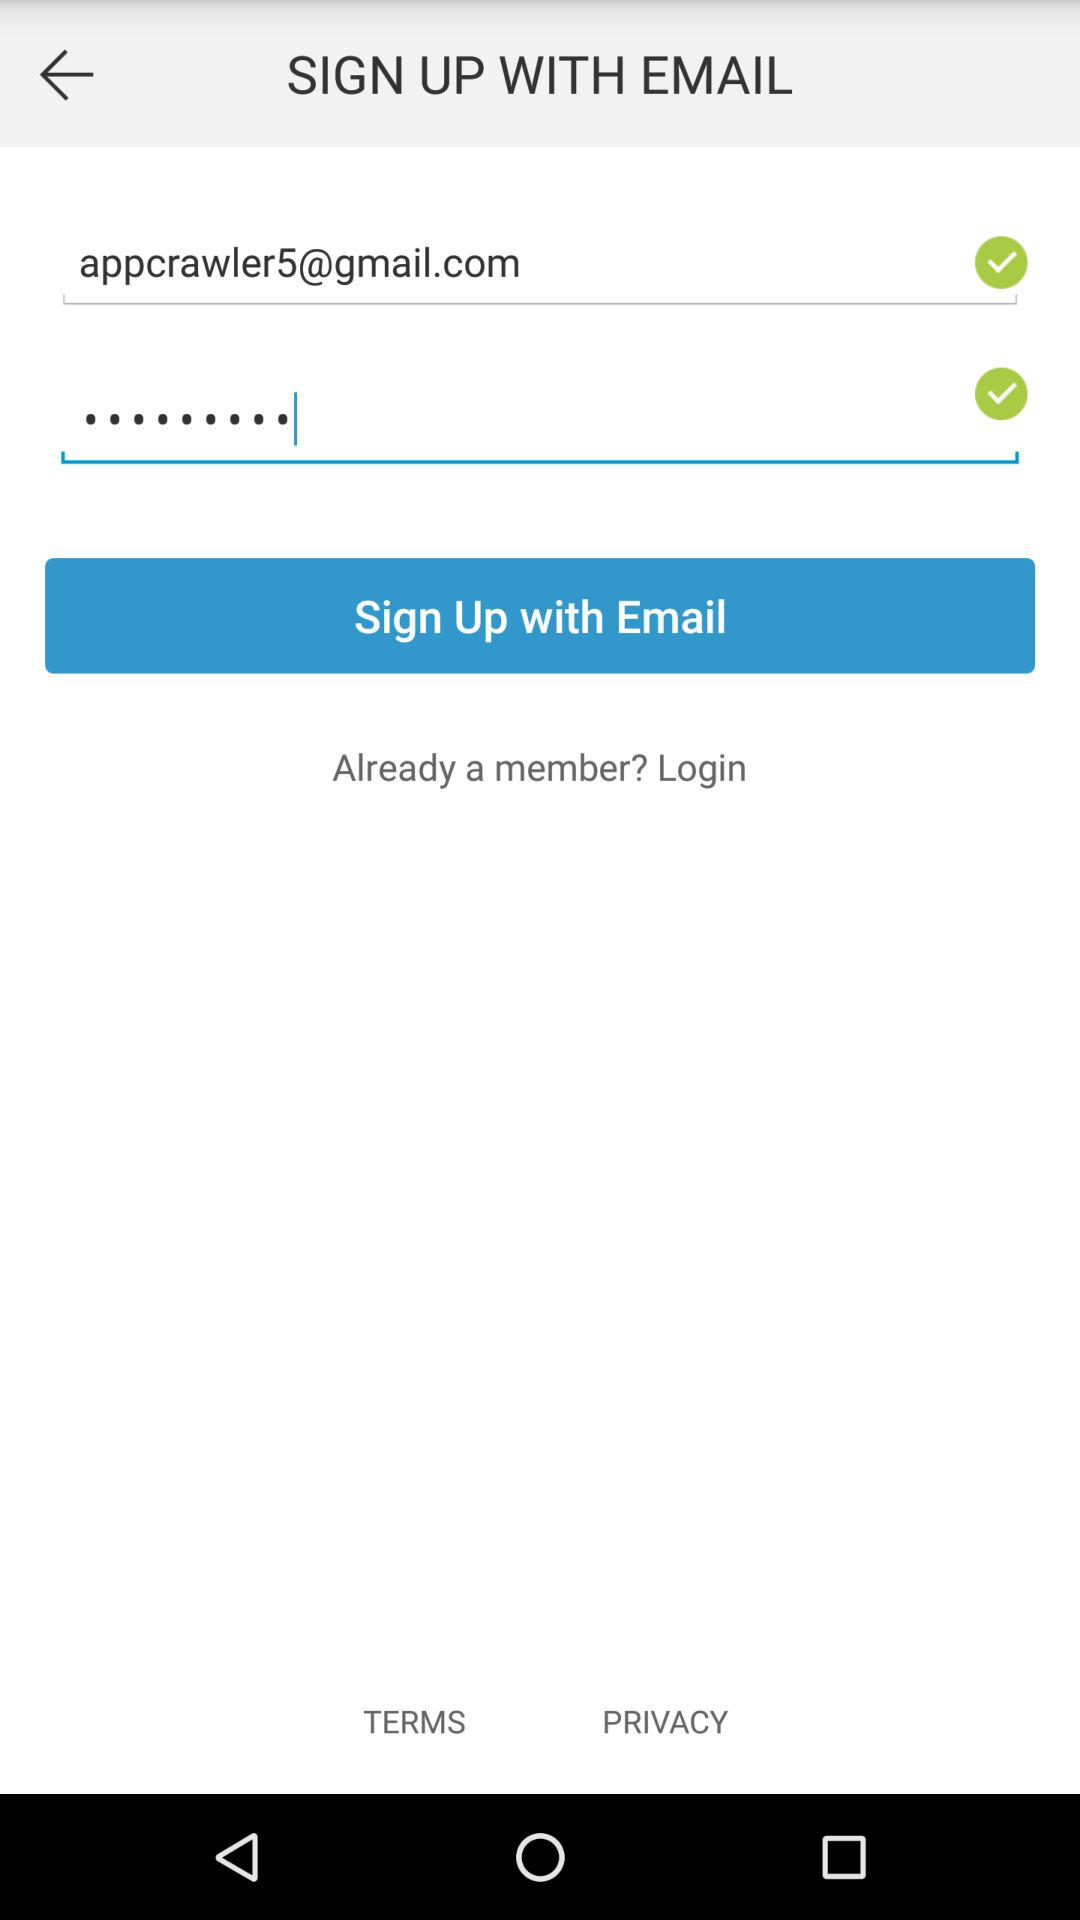How many checkboxes are on this screen?
Answer the question using a single word or phrase. 2 